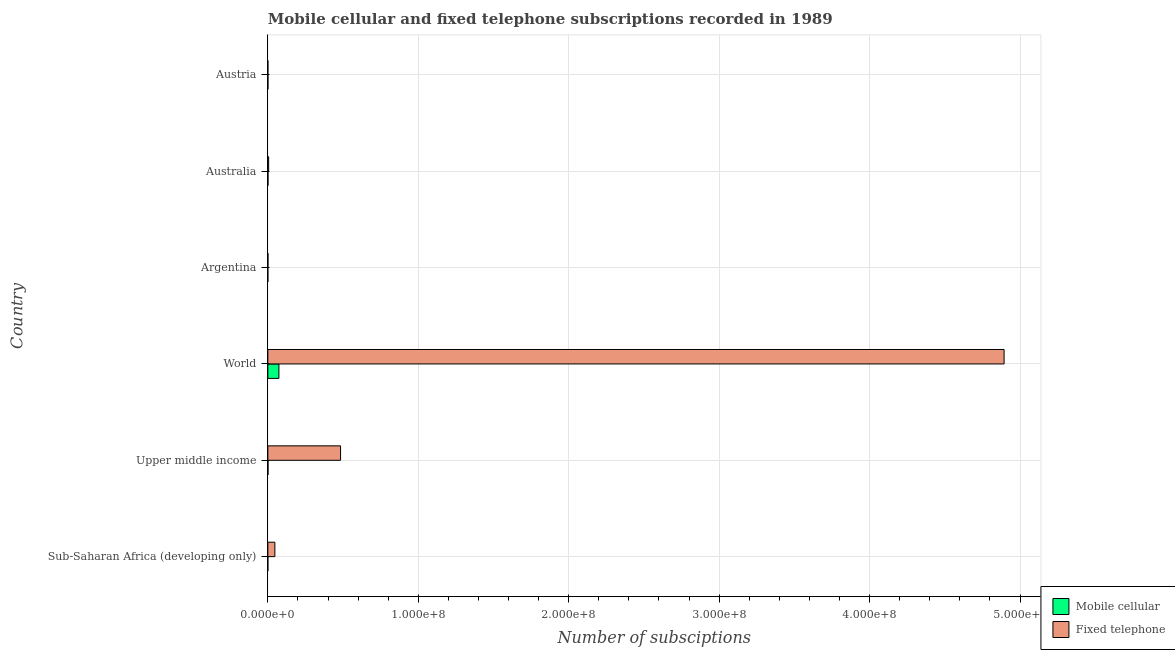How many different coloured bars are there?
Ensure brevity in your answer.  2. Are the number of bars per tick equal to the number of legend labels?
Offer a terse response. Yes. Are the number of bars on each tick of the Y-axis equal?
Your answer should be very brief. Yes. How many bars are there on the 6th tick from the top?
Give a very brief answer. 2. In how many cases, is the number of bars for a given country not equal to the number of legend labels?
Give a very brief answer. 0. What is the number of mobile cellular subscriptions in Austria?
Make the answer very short. 5.07e+04. Across all countries, what is the maximum number of fixed telephone subscriptions?
Offer a terse response. 4.89e+08. Across all countries, what is the minimum number of fixed telephone subscriptions?
Make the answer very short. 1.75e+04. In which country was the number of mobile cellular subscriptions maximum?
Your answer should be compact. World. In which country was the number of fixed telephone subscriptions minimum?
Make the answer very short. Austria. What is the total number of fixed telephone subscriptions in the graph?
Your answer should be very brief. 5.43e+08. What is the difference between the number of fixed telephone subscriptions in Australia and that in Sub-Saharan Africa (developing only)?
Make the answer very short. -4.15e+06. What is the difference between the number of fixed telephone subscriptions in World and the number of mobile cellular subscriptions in Upper middle income?
Your response must be concise. 4.89e+08. What is the average number of fixed telephone subscriptions per country?
Provide a succinct answer. 9.05e+07. What is the difference between the number of mobile cellular subscriptions and number of fixed telephone subscriptions in World?
Make the answer very short. -4.82e+08. In how many countries, is the number of mobile cellular subscriptions greater than 460000000 ?
Provide a short and direct response. 0. What is the ratio of the number of mobile cellular subscriptions in Argentina to that in Sub-Saharan Africa (developing only)?
Provide a short and direct response. 0.58. Is the number of fixed telephone subscriptions in Australia less than that in Austria?
Provide a succinct answer. No. Is the difference between the number of mobile cellular subscriptions in Sub-Saharan Africa (developing only) and World greater than the difference between the number of fixed telephone subscriptions in Sub-Saharan Africa (developing only) and World?
Give a very brief answer. Yes. What is the difference between the highest and the second highest number of fixed telephone subscriptions?
Your answer should be very brief. 4.41e+08. What is the difference between the highest and the lowest number of mobile cellular subscriptions?
Your response must be concise. 7.35e+06. Is the sum of the number of fixed telephone subscriptions in Australia and World greater than the maximum number of mobile cellular subscriptions across all countries?
Offer a very short reply. Yes. What does the 1st bar from the top in Austria represents?
Provide a short and direct response. Fixed telephone. What does the 1st bar from the bottom in Sub-Saharan Africa (developing only) represents?
Your answer should be very brief. Mobile cellular. How many bars are there?
Your answer should be very brief. 12. Are all the bars in the graph horizontal?
Your response must be concise. Yes. Are the values on the major ticks of X-axis written in scientific E-notation?
Your answer should be very brief. Yes. How are the legend labels stacked?
Provide a short and direct response. Vertical. What is the title of the graph?
Give a very brief answer. Mobile cellular and fixed telephone subscriptions recorded in 1989. What is the label or title of the X-axis?
Provide a succinct answer. Number of subsciptions. What is the Number of subsciptions in Mobile cellular in Sub-Saharan Africa (developing only)?
Your answer should be very brief. 3980. What is the Number of subsciptions of Fixed telephone in Sub-Saharan Africa (developing only)?
Make the answer very short. 4.68e+06. What is the Number of subsciptions in Mobile cellular in Upper middle income?
Your answer should be very brief. 1.18e+05. What is the Number of subsciptions of Fixed telephone in Upper middle income?
Keep it short and to the point. 4.83e+07. What is the Number of subsciptions in Mobile cellular in World?
Provide a short and direct response. 7.35e+06. What is the Number of subsciptions of Fixed telephone in World?
Give a very brief answer. 4.89e+08. What is the Number of subsciptions in Mobile cellular in Argentina?
Your answer should be very brief. 2300. What is the Number of subsciptions of Fixed telephone in Argentina?
Provide a succinct answer. 6.70e+04. What is the Number of subsciptions of Mobile cellular in Australia?
Offer a terse response. 9.45e+04. What is the Number of subsciptions of Fixed telephone in Australia?
Provide a short and direct response. 5.30e+05. What is the Number of subsciptions in Mobile cellular in Austria?
Ensure brevity in your answer.  5.07e+04. What is the Number of subsciptions in Fixed telephone in Austria?
Ensure brevity in your answer.  1.75e+04. Across all countries, what is the maximum Number of subsciptions of Mobile cellular?
Make the answer very short. 7.35e+06. Across all countries, what is the maximum Number of subsciptions of Fixed telephone?
Keep it short and to the point. 4.89e+08. Across all countries, what is the minimum Number of subsciptions in Mobile cellular?
Offer a very short reply. 2300. Across all countries, what is the minimum Number of subsciptions in Fixed telephone?
Offer a terse response. 1.75e+04. What is the total Number of subsciptions in Mobile cellular in the graph?
Offer a terse response. 7.62e+06. What is the total Number of subsciptions in Fixed telephone in the graph?
Make the answer very short. 5.43e+08. What is the difference between the Number of subsciptions in Mobile cellular in Sub-Saharan Africa (developing only) and that in Upper middle income?
Offer a very short reply. -1.14e+05. What is the difference between the Number of subsciptions of Fixed telephone in Sub-Saharan Africa (developing only) and that in Upper middle income?
Provide a succinct answer. -4.37e+07. What is the difference between the Number of subsciptions in Mobile cellular in Sub-Saharan Africa (developing only) and that in World?
Offer a very short reply. -7.35e+06. What is the difference between the Number of subsciptions of Fixed telephone in Sub-Saharan Africa (developing only) and that in World?
Provide a succinct answer. -4.85e+08. What is the difference between the Number of subsciptions of Mobile cellular in Sub-Saharan Africa (developing only) and that in Argentina?
Your answer should be very brief. 1680. What is the difference between the Number of subsciptions in Fixed telephone in Sub-Saharan Africa (developing only) and that in Argentina?
Your response must be concise. 4.61e+06. What is the difference between the Number of subsciptions of Mobile cellular in Sub-Saharan Africa (developing only) and that in Australia?
Offer a terse response. -9.05e+04. What is the difference between the Number of subsciptions of Fixed telephone in Sub-Saharan Africa (developing only) and that in Australia?
Make the answer very short. 4.15e+06. What is the difference between the Number of subsciptions in Mobile cellular in Sub-Saharan Africa (developing only) and that in Austria?
Give a very brief answer. -4.67e+04. What is the difference between the Number of subsciptions of Fixed telephone in Sub-Saharan Africa (developing only) and that in Austria?
Your answer should be very brief. 4.66e+06. What is the difference between the Number of subsciptions of Mobile cellular in Upper middle income and that in World?
Offer a very short reply. -7.24e+06. What is the difference between the Number of subsciptions in Fixed telephone in Upper middle income and that in World?
Your answer should be very brief. -4.41e+08. What is the difference between the Number of subsciptions in Mobile cellular in Upper middle income and that in Argentina?
Ensure brevity in your answer.  1.16e+05. What is the difference between the Number of subsciptions in Fixed telephone in Upper middle income and that in Argentina?
Make the answer very short. 4.83e+07. What is the difference between the Number of subsciptions in Mobile cellular in Upper middle income and that in Australia?
Offer a very short reply. 2.34e+04. What is the difference between the Number of subsciptions in Fixed telephone in Upper middle income and that in Australia?
Give a very brief answer. 4.78e+07. What is the difference between the Number of subsciptions of Mobile cellular in Upper middle income and that in Austria?
Your answer should be compact. 6.72e+04. What is the difference between the Number of subsciptions of Fixed telephone in Upper middle income and that in Austria?
Keep it short and to the point. 4.83e+07. What is the difference between the Number of subsciptions in Mobile cellular in World and that in Argentina?
Ensure brevity in your answer.  7.35e+06. What is the difference between the Number of subsciptions of Fixed telephone in World and that in Argentina?
Keep it short and to the point. 4.89e+08. What is the difference between the Number of subsciptions of Mobile cellular in World and that in Australia?
Your response must be concise. 7.26e+06. What is the difference between the Number of subsciptions in Fixed telephone in World and that in Australia?
Ensure brevity in your answer.  4.89e+08. What is the difference between the Number of subsciptions in Mobile cellular in World and that in Austria?
Offer a terse response. 7.30e+06. What is the difference between the Number of subsciptions of Fixed telephone in World and that in Austria?
Your answer should be very brief. 4.89e+08. What is the difference between the Number of subsciptions in Mobile cellular in Argentina and that in Australia?
Ensure brevity in your answer.  -9.22e+04. What is the difference between the Number of subsciptions in Fixed telephone in Argentina and that in Australia?
Offer a terse response. -4.63e+05. What is the difference between the Number of subsciptions in Mobile cellular in Argentina and that in Austria?
Ensure brevity in your answer.  -4.84e+04. What is the difference between the Number of subsciptions of Fixed telephone in Argentina and that in Austria?
Provide a short and direct response. 4.95e+04. What is the difference between the Number of subsciptions of Mobile cellular in Australia and that in Austria?
Keep it short and to the point. 4.38e+04. What is the difference between the Number of subsciptions in Fixed telephone in Australia and that in Austria?
Ensure brevity in your answer.  5.13e+05. What is the difference between the Number of subsciptions of Mobile cellular in Sub-Saharan Africa (developing only) and the Number of subsciptions of Fixed telephone in Upper middle income?
Ensure brevity in your answer.  -4.83e+07. What is the difference between the Number of subsciptions in Mobile cellular in Sub-Saharan Africa (developing only) and the Number of subsciptions in Fixed telephone in World?
Offer a very short reply. -4.89e+08. What is the difference between the Number of subsciptions in Mobile cellular in Sub-Saharan Africa (developing only) and the Number of subsciptions in Fixed telephone in Argentina?
Offer a very short reply. -6.30e+04. What is the difference between the Number of subsciptions of Mobile cellular in Sub-Saharan Africa (developing only) and the Number of subsciptions of Fixed telephone in Australia?
Provide a short and direct response. -5.26e+05. What is the difference between the Number of subsciptions in Mobile cellular in Sub-Saharan Africa (developing only) and the Number of subsciptions in Fixed telephone in Austria?
Keep it short and to the point. -1.35e+04. What is the difference between the Number of subsciptions in Mobile cellular in Upper middle income and the Number of subsciptions in Fixed telephone in World?
Your response must be concise. -4.89e+08. What is the difference between the Number of subsciptions in Mobile cellular in Upper middle income and the Number of subsciptions in Fixed telephone in Argentina?
Provide a succinct answer. 5.09e+04. What is the difference between the Number of subsciptions in Mobile cellular in Upper middle income and the Number of subsciptions in Fixed telephone in Australia?
Offer a very short reply. -4.12e+05. What is the difference between the Number of subsciptions of Mobile cellular in Upper middle income and the Number of subsciptions of Fixed telephone in Austria?
Offer a terse response. 1.00e+05. What is the difference between the Number of subsciptions in Mobile cellular in World and the Number of subsciptions in Fixed telephone in Argentina?
Provide a succinct answer. 7.29e+06. What is the difference between the Number of subsciptions in Mobile cellular in World and the Number of subsciptions in Fixed telephone in Australia?
Provide a short and direct response. 6.82e+06. What is the difference between the Number of subsciptions of Mobile cellular in World and the Number of subsciptions of Fixed telephone in Austria?
Ensure brevity in your answer.  7.34e+06. What is the difference between the Number of subsciptions of Mobile cellular in Argentina and the Number of subsciptions of Fixed telephone in Australia?
Your answer should be very brief. -5.28e+05. What is the difference between the Number of subsciptions of Mobile cellular in Argentina and the Number of subsciptions of Fixed telephone in Austria?
Your answer should be very brief. -1.52e+04. What is the difference between the Number of subsciptions of Mobile cellular in Australia and the Number of subsciptions of Fixed telephone in Austria?
Offer a very short reply. 7.71e+04. What is the average Number of subsciptions in Mobile cellular per country?
Provide a succinct answer. 1.27e+06. What is the average Number of subsciptions in Fixed telephone per country?
Your response must be concise. 9.05e+07. What is the difference between the Number of subsciptions in Mobile cellular and Number of subsciptions in Fixed telephone in Sub-Saharan Africa (developing only)?
Provide a short and direct response. -4.67e+06. What is the difference between the Number of subsciptions in Mobile cellular and Number of subsciptions in Fixed telephone in Upper middle income?
Your answer should be very brief. -4.82e+07. What is the difference between the Number of subsciptions of Mobile cellular and Number of subsciptions of Fixed telephone in World?
Your answer should be compact. -4.82e+08. What is the difference between the Number of subsciptions of Mobile cellular and Number of subsciptions of Fixed telephone in Argentina?
Ensure brevity in your answer.  -6.47e+04. What is the difference between the Number of subsciptions in Mobile cellular and Number of subsciptions in Fixed telephone in Australia?
Offer a terse response. -4.35e+05. What is the difference between the Number of subsciptions of Mobile cellular and Number of subsciptions of Fixed telephone in Austria?
Ensure brevity in your answer.  3.33e+04. What is the ratio of the Number of subsciptions in Mobile cellular in Sub-Saharan Africa (developing only) to that in Upper middle income?
Ensure brevity in your answer.  0.03. What is the ratio of the Number of subsciptions of Fixed telephone in Sub-Saharan Africa (developing only) to that in Upper middle income?
Provide a succinct answer. 0.1. What is the ratio of the Number of subsciptions in Mobile cellular in Sub-Saharan Africa (developing only) to that in World?
Offer a terse response. 0. What is the ratio of the Number of subsciptions in Fixed telephone in Sub-Saharan Africa (developing only) to that in World?
Ensure brevity in your answer.  0.01. What is the ratio of the Number of subsciptions in Mobile cellular in Sub-Saharan Africa (developing only) to that in Argentina?
Keep it short and to the point. 1.73. What is the ratio of the Number of subsciptions of Fixed telephone in Sub-Saharan Africa (developing only) to that in Argentina?
Make the answer very short. 69.81. What is the ratio of the Number of subsciptions in Mobile cellular in Sub-Saharan Africa (developing only) to that in Australia?
Provide a succinct answer. 0.04. What is the ratio of the Number of subsciptions in Fixed telephone in Sub-Saharan Africa (developing only) to that in Australia?
Provide a succinct answer. 8.82. What is the ratio of the Number of subsciptions of Mobile cellular in Sub-Saharan Africa (developing only) to that in Austria?
Offer a terse response. 0.08. What is the ratio of the Number of subsciptions in Fixed telephone in Sub-Saharan Africa (developing only) to that in Austria?
Provide a succinct answer. 267.73. What is the ratio of the Number of subsciptions in Mobile cellular in Upper middle income to that in World?
Your response must be concise. 0.02. What is the ratio of the Number of subsciptions of Fixed telephone in Upper middle income to that in World?
Keep it short and to the point. 0.1. What is the ratio of the Number of subsciptions of Mobile cellular in Upper middle income to that in Argentina?
Your answer should be very brief. 51.25. What is the ratio of the Number of subsciptions of Fixed telephone in Upper middle income to that in Argentina?
Make the answer very short. 721.41. What is the ratio of the Number of subsciptions of Mobile cellular in Upper middle income to that in Australia?
Keep it short and to the point. 1.25. What is the ratio of the Number of subsciptions in Fixed telephone in Upper middle income to that in Australia?
Make the answer very short. 91.2. What is the ratio of the Number of subsciptions of Mobile cellular in Upper middle income to that in Austria?
Provide a short and direct response. 2.32. What is the ratio of the Number of subsciptions in Fixed telephone in Upper middle income to that in Austria?
Offer a very short reply. 2766.87. What is the ratio of the Number of subsciptions in Mobile cellular in World to that in Argentina?
Offer a very short reply. 3196.99. What is the ratio of the Number of subsciptions of Fixed telephone in World to that in Argentina?
Your response must be concise. 7304.51. What is the ratio of the Number of subsciptions of Mobile cellular in World to that in Australia?
Give a very brief answer. 77.79. What is the ratio of the Number of subsciptions of Fixed telephone in World to that in Australia?
Keep it short and to the point. 923.4. What is the ratio of the Number of subsciptions of Mobile cellular in World to that in Austria?
Keep it short and to the point. 144.97. What is the ratio of the Number of subsciptions of Fixed telephone in World to that in Austria?
Offer a terse response. 2.80e+04. What is the ratio of the Number of subsciptions in Mobile cellular in Argentina to that in Australia?
Offer a very short reply. 0.02. What is the ratio of the Number of subsciptions of Fixed telephone in Argentina to that in Australia?
Keep it short and to the point. 0.13. What is the ratio of the Number of subsciptions in Mobile cellular in Argentina to that in Austria?
Give a very brief answer. 0.05. What is the ratio of the Number of subsciptions of Fixed telephone in Argentina to that in Austria?
Your answer should be compact. 3.84. What is the ratio of the Number of subsciptions of Mobile cellular in Australia to that in Austria?
Provide a short and direct response. 1.86. What is the ratio of the Number of subsciptions of Fixed telephone in Australia to that in Austria?
Your answer should be compact. 30.34. What is the difference between the highest and the second highest Number of subsciptions of Mobile cellular?
Offer a terse response. 7.24e+06. What is the difference between the highest and the second highest Number of subsciptions in Fixed telephone?
Offer a terse response. 4.41e+08. What is the difference between the highest and the lowest Number of subsciptions of Mobile cellular?
Give a very brief answer. 7.35e+06. What is the difference between the highest and the lowest Number of subsciptions of Fixed telephone?
Make the answer very short. 4.89e+08. 